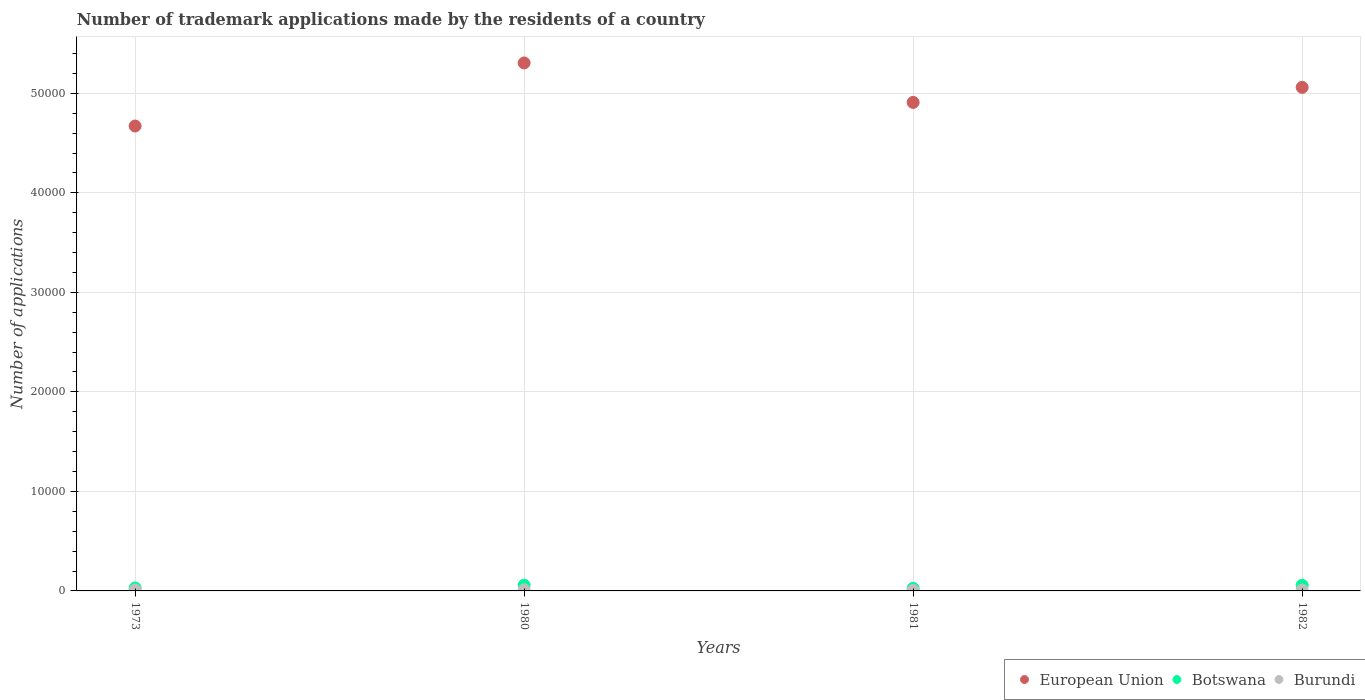Is the number of dotlines equal to the number of legend labels?
Your answer should be very brief. Yes. What is the number of trademark applications made by the residents in Burundi in 1981?
Provide a short and direct response. 66. Across all years, what is the maximum number of trademark applications made by the residents in Burundi?
Keep it short and to the point. 110. Across all years, what is the minimum number of trademark applications made by the residents in European Union?
Provide a short and direct response. 4.67e+04. What is the total number of trademark applications made by the residents in Botswana in the graph?
Offer a very short reply. 1702. What is the difference between the number of trademark applications made by the residents in European Union in 1973 and that in 1982?
Your answer should be very brief. -3883. What is the difference between the number of trademark applications made by the residents in European Union in 1981 and the number of trademark applications made by the residents in Botswana in 1982?
Offer a terse response. 4.85e+04. What is the average number of trademark applications made by the residents in Burundi per year?
Provide a succinct answer. 91.25. In the year 1981, what is the difference between the number of trademark applications made by the residents in European Union and number of trademark applications made by the residents in Botswana?
Offer a terse response. 4.88e+04. What is the ratio of the number of trademark applications made by the residents in Burundi in 1973 to that in 1980?
Your answer should be compact. 0.85. Is the difference between the number of trademark applications made by the residents in European Union in 1980 and 1981 greater than the difference between the number of trademark applications made by the residents in Botswana in 1980 and 1981?
Provide a succinct answer. Yes. What is the difference between the highest and the lowest number of trademark applications made by the residents in Botswana?
Provide a succinct answer. 311. Is the sum of the number of trademark applications made by the residents in Botswana in 1981 and 1982 greater than the maximum number of trademark applications made by the residents in European Union across all years?
Your answer should be very brief. No. Does the number of trademark applications made by the residents in Botswana monotonically increase over the years?
Provide a succinct answer. No. How many dotlines are there?
Make the answer very short. 3. Are the values on the major ticks of Y-axis written in scientific E-notation?
Offer a terse response. No. Does the graph contain grids?
Keep it short and to the point. Yes. Where does the legend appear in the graph?
Provide a short and direct response. Bottom right. What is the title of the graph?
Provide a short and direct response. Number of trademark applications made by the residents of a country. Does "European Union" appear as one of the legend labels in the graph?
Your answer should be very brief. Yes. What is the label or title of the X-axis?
Your response must be concise. Years. What is the label or title of the Y-axis?
Offer a terse response. Number of applications. What is the Number of applications in European Union in 1973?
Your answer should be compact. 4.67e+04. What is the Number of applications in Botswana in 1973?
Provide a succinct answer. 301. What is the Number of applications in Burundi in 1973?
Offer a terse response. 94. What is the Number of applications in European Union in 1980?
Ensure brevity in your answer.  5.31e+04. What is the Number of applications in Botswana in 1980?
Give a very brief answer. 573. What is the Number of applications of Burundi in 1980?
Your answer should be very brief. 110. What is the Number of applications of European Union in 1981?
Offer a terse response. 4.91e+04. What is the Number of applications of Botswana in 1981?
Give a very brief answer. 262. What is the Number of applications in Burundi in 1981?
Ensure brevity in your answer.  66. What is the Number of applications in European Union in 1982?
Give a very brief answer. 5.06e+04. What is the Number of applications of Botswana in 1982?
Provide a succinct answer. 566. Across all years, what is the maximum Number of applications in European Union?
Your answer should be compact. 5.31e+04. Across all years, what is the maximum Number of applications of Botswana?
Your response must be concise. 573. Across all years, what is the maximum Number of applications in Burundi?
Give a very brief answer. 110. Across all years, what is the minimum Number of applications in European Union?
Give a very brief answer. 4.67e+04. Across all years, what is the minimum Number of applications of Botswana?
Keep it short and to the point. 262. What is the total Number of applications of European Union in the graph?
Your answer should be compact. 1.99e+05. What is the total Number of applications in Botswana in the graph?
Provide a short and direct response. 1702. What is the total Number of applications of Burundi in the graph?
Give a very brief answer. 365. What is the difference between the Number of applications in European Union in 1973 and that in 1980?
Ensure brevity in your answer.  -6337. What is the difference between the Number of applications in Botswana in 1973 and that in 1980?
Offer a terse response. -272. What is the difference between the Number of applications in Burundi in 1973 and that in 1980?
Your answer should be very brief. -16. What is the difference between the Number of applications of European Union in 1973 and that in 1981?
Provide a short and direct response. -2372. What is the difference between the Number of applications of Botswana in 1973 and that in 1981?
Your answer should be very brief. 39. What is the difference between the Number of applications of Burundi in 1973 and that in 1981?
Provide a succinct answer. 28. What is the difference between the Number of applications of European Union in 1973 and that in 1982?
Keep it short and to the point. -3883. What is the difference between the Number of applications in Botswana in 1973 and that in 1982?
Make the answer very short. -265. What is the difference between the Number of applications of Burundi in 1973 and that in 1982?
Provide a short and direct response. -1. What is the difference between the Number of applications of European Union in 1980 and that in 1981?
Provide a short and direct response. 3965. What is the difference between the Number of applications in Botswana in 1980 and that in 1981?
Provide a succinct answer. 311. What is the difference between the Number of applications of Burundi in 1980 and that in 1981?
Give a very brief answer. 44. What is the difference between the Number of applications of European Union in 1980 and that in 1982?
Make the answer very short. 2454. What is the difference between the Number of applications in European Union in 1981 and that in 1982?
Your response must be concise. -1511. What is the difference between the Number of applications of Botswana in 1981 and that in 1982?
Make the answer very short. -304. What is the difference between the Number of applications in Burundi in 1981 and that in 1982?
Ensure brevity in your answer.  -29. What is the difference between the Number of applications in European Union in 1973 and the Number of applications in Botswana in 1980?
Make the answer very short. 4.61e+04. What is the difference between the Number of applications in European Union in 1973 and the Number of applications in Burundi in 1980?
Provide a short and direct response. 4.66e+04. What is the difference between the Number of applications in Botswana in 1973 and the Number of applications in Burundi in 1980?
Offer a terse response. 191. What is the difference between the Number of applications of European Union in 1973 and the Number of applications of Botswana in 1981?
Offer a very short reply. 4.65e+04. What is the difference between the Number of applications in European Union in 1973 and the Number of applications in Burundi in 1981?
Make the answer very short. 4.66e+04. What is the difference between the Number of applications of Botswana in 1973 and the Number of applications of Burundi in 1981?
Your response must be concise. 235. What is the difference between the Number of applications of European Union in 1973 and the Number of applications of Botswana in 1982?
Offer a very short reply. 4.61e+04. What is the difference between the Number of applications of European Union in 1973 and the Number of applications of Burundi in 1982?
Your response must be concise. 4.66e+04. What is the difference between the Number of applications of Botswana in 1973 and the Number of applications of Burundi in 1982?
Your response must be concise. 206. What is the difference between the Number of applications in European Union in 1980 and the Number of applications in Botswana in 1981?
Give a very brief answer. 5.28e+04. What is the difference between the Number of applications in European Union in 1980 and the Number of applications in Burundi in 1981?
Make the answer very short. 5.30e+04. What is the difference between the Number of applications in Botswana in 1980 and the Number of applications in Burundi in 1981?
Make the answer very short. 507. What is the difference between the Number of applications of European Union in 1980 and the Number of applications of Botswana in 1982?
Make the answer very short. 5.25e+04. What is the difference between the Number of applications in European Union in 1980 and the Number of applications in Burundi in 1982?
Keep it short and to the point. 5.30e+04. What is the difference between the Number of applications of Botswana in 1980 and the Number of applications of Burundi in 1982?
Give a very brief answer. 478. What is the difference between the Number of applications in European Union in 1981 and the Number of applications in Botswana in 1982?
Offer a very short reply. 4.85e+04. What is the difference between the Number of applications of European Union in 1981 and the Number of applications of Burundi in 1982?
Keep it short and to the point. 4.90e+04. What is the difference between the Number of applications of Botswana in 1981 and the Number of applications of Burundi in 1982?
Ensure brevity in your answer.  167. What is the average Number of applications in European Union per year?
Provide a succinct answer. 4.99e+04. What is the average Number of applications in Botswana per year?
Offer a very short reply. 425.5. What is the average Number of applications in Burundi per year?
Offer a terse response. 91.25. In the year 1973, what is the difference between the Number of applications in European Union and Number of applications in Botswana?
Provide a succinct answer. 4.64e+04. In the year 1973, what is the difference between the Number of applications in European Union and Number of applications in Burundi?
Provide a short and direct response. 4.66e+04. In the year 1973, what is the difference between the Number of applications of Botswana and Number of applications of Burundi?
Provide a short and direct response. 207. In the year 1980, what is the difference between the Number of applications of European Union and Number of applications of Botswana?
Provide a succinct answer. 5.25e+04. In the year 1980, what is the difference between the Number of applications of European Union and Number of applications of Burundi?
Offer a terse response. 5.29e+04. In the year 1980, what is the difference between the Number of applications of Botswana and Number of applications of Burundi?
Your response must be concise. 463. In the year 1981, what is the difference between the Number of applications of European Union and Number of applications of Botswana?
Your response must be concise. 4.88e+04. In the year 1981, what is the difference between the Number of applications of European Union and Number of applications of Burundi?
Your answer should be very brief. 4.90e+04. In the year 1981, what is the difference between the Number of applications in Botswana and Number of applications in Burundi?
Provide a short and direct response. 196. In the year 1982, what is the difference between the Number of applications of European Union and Number of applications of Botswana?
Your answer should be very brief. 5.00e+04. In the year 1982, what is the difference between the Number of applications of European Union and Number of applications of Burundi?
Keep it short and to the point. 5.05e+04. In the year 1982, what is the difference between the Number of applications in Botswana and Number of applications in Burundi?
Offer a very short reply. 471. What is the ratio of the Number of applications of European Union in 1973 to that in 1980?
Your response must be concise. 0.88. What is the ratio of the Number of applications of Botswana in 1973 to that in 1980?
Make the answer very short. 0.53. What is the ratio of the Number of applications in Burundi in 1973 to that in 1980?
Offer a very short reply. 0.85. What is the ratio of the Number of applications of European Union in 1973 to that in 1981?
Your answer should be compact. 0.95. What is the ratio of the Number of applications of Botswana in 1973 to that in 1981?
Give a very brief answer. 1.15. What is the ratio of the Number of applications in Burundi in 1973 to that in 1981?
Your answer should be very brief. 1.42. What is the ratio of the Number of applications of European Union in 1973 to that in 1982?
Provide a short and direct response. 0.92. What is the ratio of the Number of applications of Botswana in 1973 to that in 1982?
Make the answer very short. 0.53. What is the ratio of the Number of applications in European Union in 1980 to that in 1981?
Give a very brief answer. 1.08. What is the ratio of the Number of applications of Botswana in 1980 to that in 1981?
Provide a short and direct response. 2.19. What is the ratio of the Number of applications in European Union in 1980 to that in 1982?
Make the answer very short. 1.05. What is the ratio of the Number of applications of Botswana in 1980 to that in 1982?
Your answer should be compact. 1.01. What is the ratio of the Number of applications of Burundi in 1980 to that in 1982?
Make the answer very short. 1.16. What is the ratio of the Number of applications in European Union in 1981 to that in 1982?
Make the answer very short. 0.97. What is the ratio of the Number of applications of Botswana in 1981 to that in 1982?
Your answer should be compact. 0.46. What is the ratio of the Number of applications in Burundi in 1981 to that in 1982?
Your response must be concise. 0.69. What is the difference between the highest and the second highest Number of applications of European Union?
Offer a terse response. 2454. What is the difference between the highest and the lowest Number of applications in European Union?
Make the answer very short. 6337. What is the difference between the highest and the lowest Number of applications of Botswana?
Offer a terse response. 311. What is the difference between the highest and the lowest Number of applications in Burundi?
Make the answer very short. 44. 